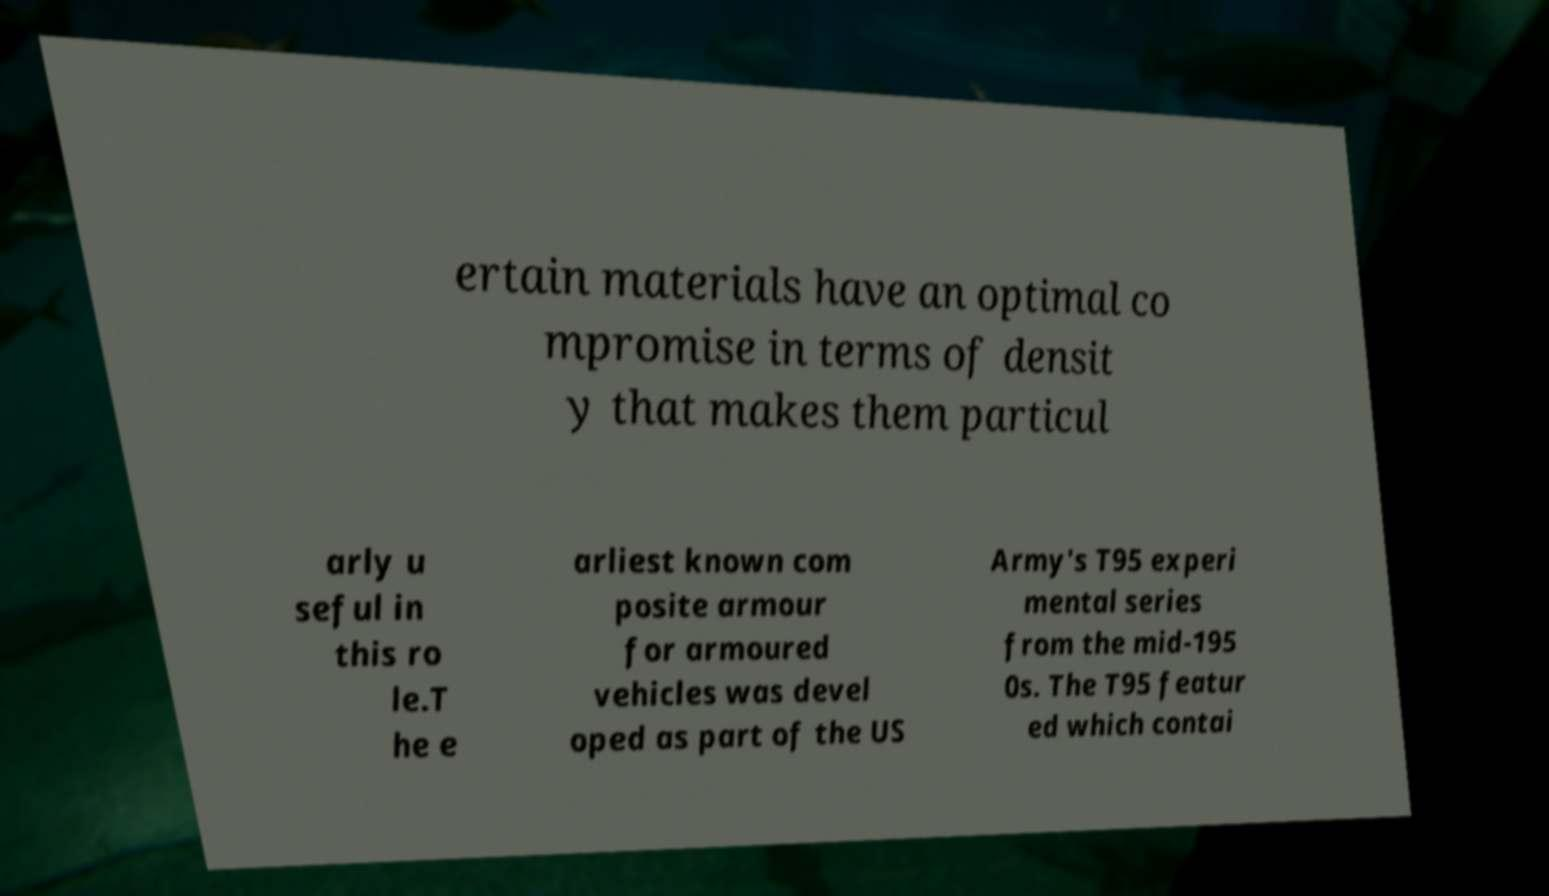Could you extract and type out the text from this image? ertain materials have an optimal co mpromise in terms of densit y that makes them particul arly u seful in this ro le.T he e arliest known com posite armour for armoured vehicles was devel oped as part of the US Army's T95 experi mental series from the mid-195 0s. The T95 featur ed which contai 